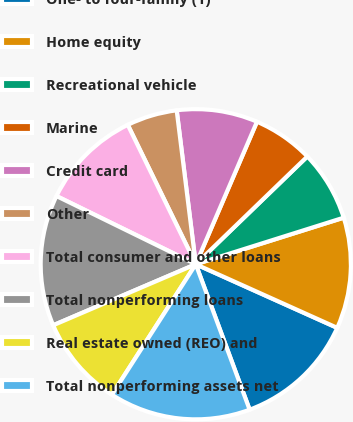Convert chart to OTSL. <chart><loc_0><loc_0><loc_500><loc_500><pie_chart><fcel>One- to four-family (1)<fcel>Home equity<fcel>Recreational vehicle<fcel>Marine<fcel>Credit card<fcel>Other<fcel>Total consumer and other loans<fcel>Total nonperforming loans<fcel>Real estate owned (REO) and<fcel>Total nonperforming assets net<nl><fcel>12.63%<fcel>11.58%<fcel>7.37%<fcel>6.32%<fcel>8.42%<fcel>5.26%<fcel>10.53%<fcel>13.68%<fcel>9.47%<fcel>14.74%<nl></chart> 